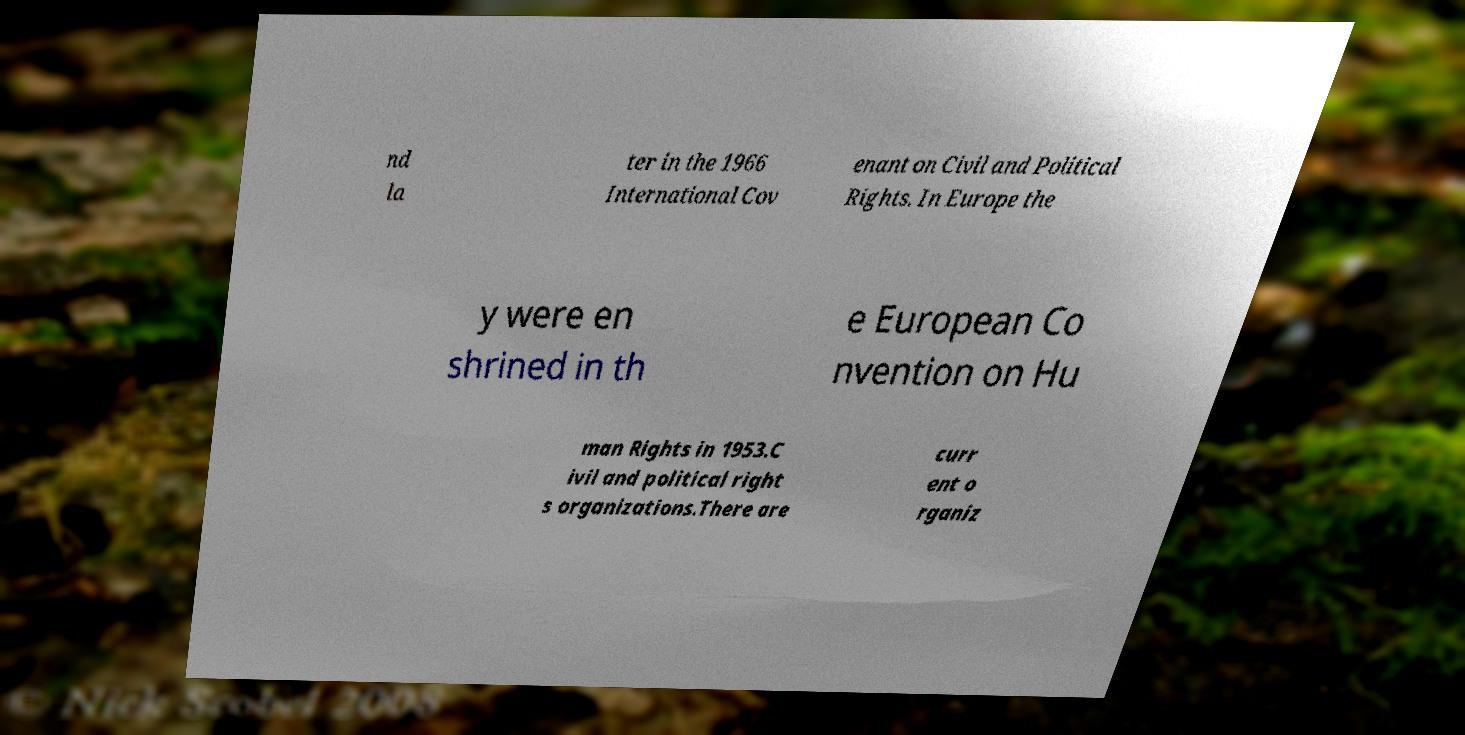Please identify and transcribe the text found in this image. nd la ter in the 1966 International Cov enant on Civil and Political Rights. In Europe the y were en shrined in th e European Co nvention on Hu man Rights in 1953.C ivil and political right s organizations.There are curr ent o rganiz 